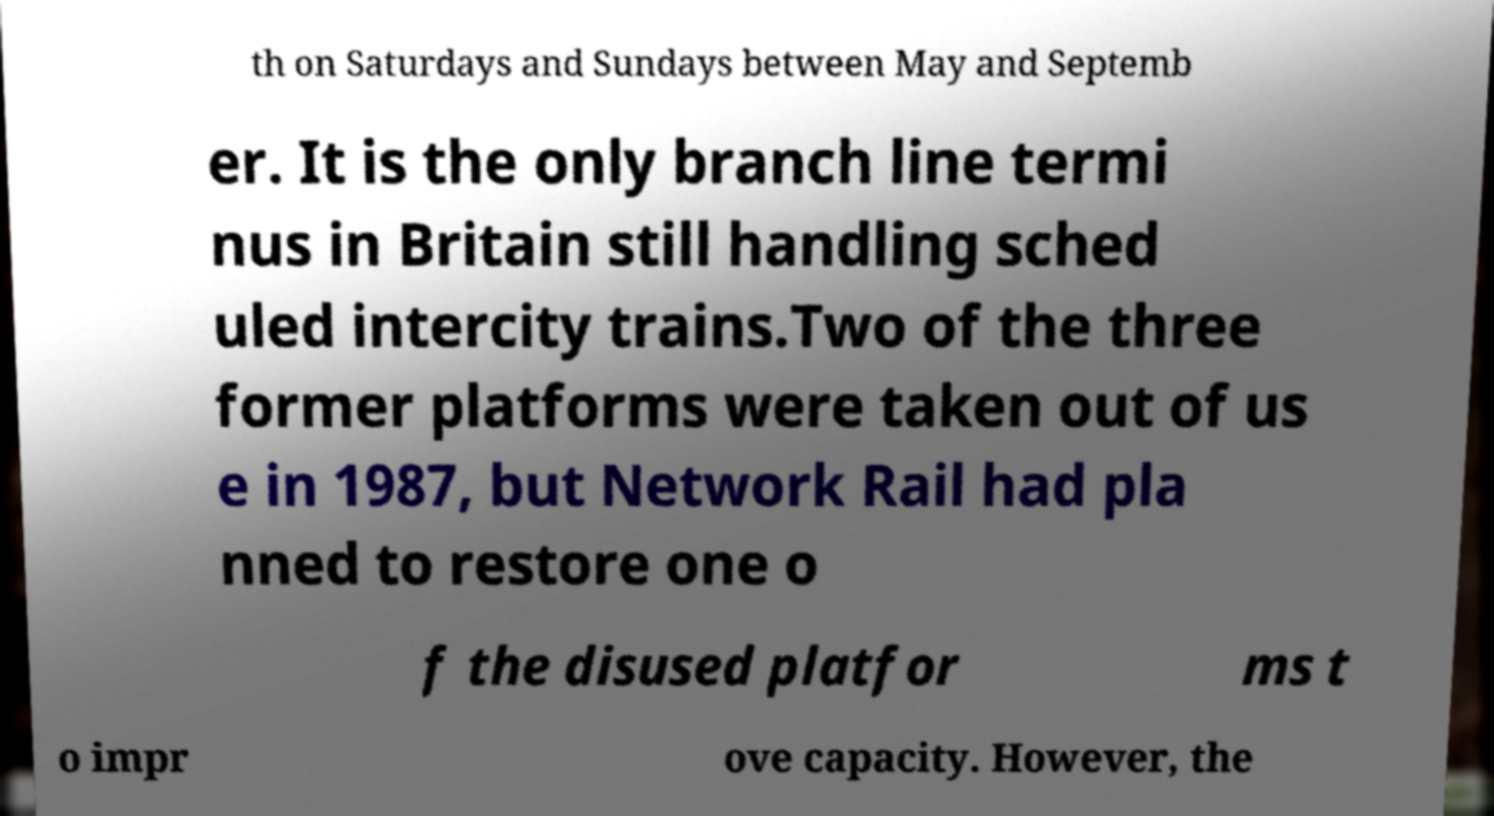Could you extract and type out the text from this image? th on Saturdays and Sundays between May and Septemb er. It is the only branch line termi nus in Britain still handling sched uled intercity trains.Two of the three former platforms were taken out of us e in 1987, but Network Rail had pla nned to restore one o f the disused platfor ms t o impr ove capacity. However, the 